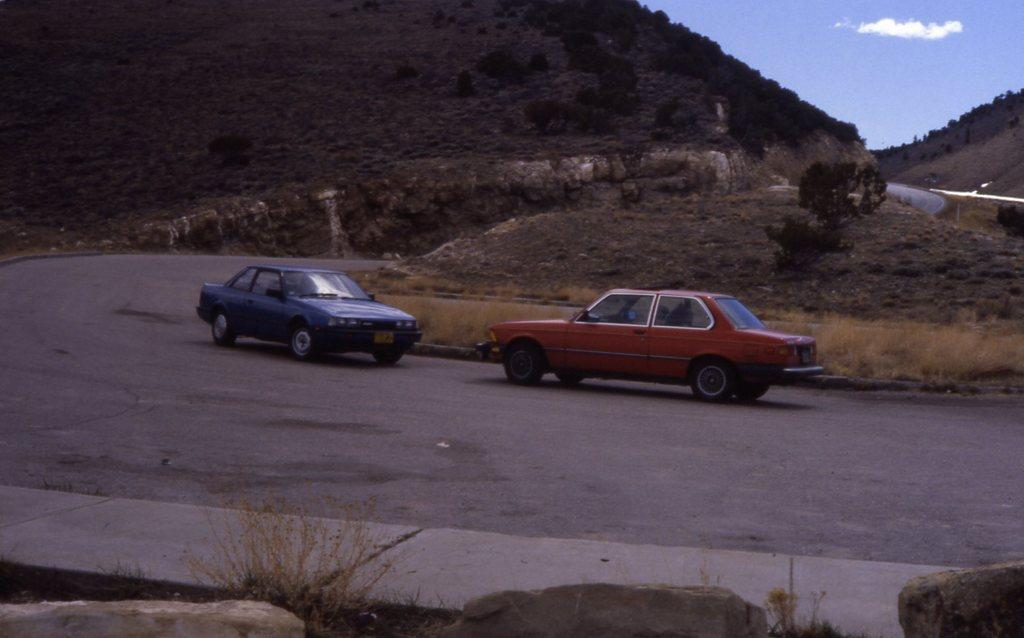What vehicles are located in the middle of the image? There are two cars in the middle of the image. What can be seen at the bottom of the image? There are plants and stones at the bottom of the image, as well as a road. What is visible in the background of the image? There are hills, trees, sky, and clouds in the background of the image. What is the range of the expansion in the image? There is no expansion mentioned in the image, as it features two cars, plants, stones, a road, hills, trees, sky, and clouds. What rule applies to the arrangement of the clouds in the image? There is no rule mentioned or implied regarding the arrangement of the clouds in the image; they are simply visible in the sky. 